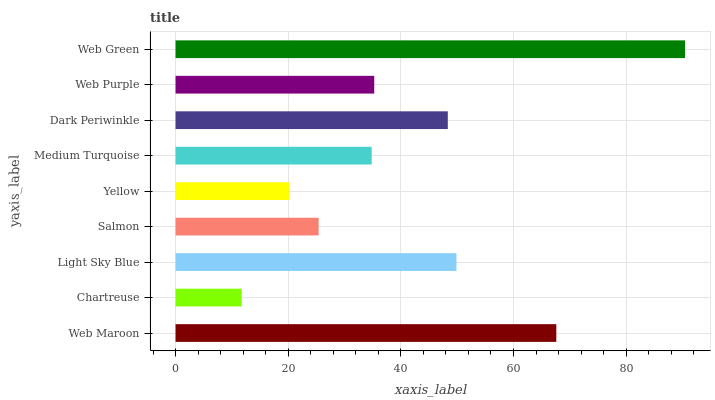Is Chartreuse the minimum?
Answer yes or no. Yes. Is Web Green the maximum?
Answer yes or no. Yes. Is Light Sky Blue the minimum?
Answer yes or no. No. Is Light Sky Blue the maximum?
Answer yes or no. No. Is Light Sky Blue greater than Chartreuse?
Answer yes or no. Yes. Is Chartreuse less than Light Sky Blue?
Answer yes or no. Yes. Is Chartreuse greater than Light Sky Blue?
Answer yes or no. No. Is Light Sky Blue less than Chartreuse?
Answer yes or no. No. Is Web Purple the high median?
Answer yes or no. Yes. Is Web Purple the low median?
Answer yes or no. Yes. Is Web Green the high median?
Answer yes or no. No. Is Light Sky Blue the low median?
Answer yes or no. No. 